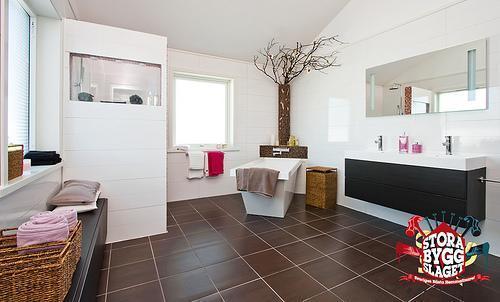How many windows are there?
Give a very brief answer. 2. 